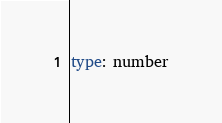<code> <loc_0><loc_0><loc_500><loc_500><_YAML_>type: number
</code> 